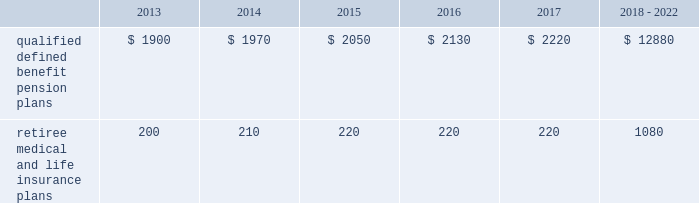Valuation techniques 2013 cash equivalents are mostly comprised of short-term money-market instruments and are valued at cost , which approximates fair value .
U.s .
Equity securities and international equity securities categorized as level 1 are traded on active national and international exchanges and are valued at their closing prices on the last trading day of the year .
For u.s .
Equity securities and international equity securities not traded on an active exchange , or if the closing price is not available , the trustee obtains indicative quotes from a pricing vendor , broker , or investment manager .
These securities are categorized as level 2 if the custodian obtains corroborated quotes from a pricing vendor or categorized as level 3 if the custodian obtains uncorroborated quotes from a broker or investment manager .
Commingled equity funds are public investment vehicles valued using the net asset value ( nav ) provided by the fund manager .
The nav is the total value of the fund divided by the number of shares outstanding .
Commingled equity funds are categorized as level 1 if traded at their nav on a nationally recognized securities exchange or categorized as level 2 if the nav is corroborated by observable market data ( e.g. , purchases or sales activity ) .
Fixed income securities categorized as level 2 are valued by the trustee using pricing models that use verifiable observable market data ( e.g .
Interest rates and yield curves observable at commonly quoted intervals ) , bids provided by brokers or dealers , or quoted prices of securities with similar characteristics .
Private equity funds , real estate funds , hedge funds , and fixed income securities categorized as level 3 are valued based on valuation models that include significant unobservable inputs and cannot be corroborated using verifiable observable market data .
Valuations for private equity funds and real estate funds are determined by the general partners , while hedge funds are valued by independent administrators .
Depending on the nature of the assets , the general partners or independent administrators use both the income and market approaches in their models .
The market approach consists of analyzing market transactions for comparable assets while the income approach uses earnings or the net present value of estimated future cash flows adjusted for liquidity and other risk factors .
Commodities categorized as level 1 are traded on an active commodity exchange and are valued at their closing prices on the last trading day of the year .
Commodities categorized as level 2 represent shares in a commingled commodity fund valued using the nav , which is corroborated by observable market data .
Contributions and expected benefit payments we generally determine funding requirements for our defined benefit pension plans in a manner consistent with cas and internal revenue code rules .
In 2012 , we made contributions of $ 3.6 billion related to our qualified defined benefit pension plans .
We plan to make contributions of approximately $ 1.5 billion related to the qualified defined benefit pension plans in 2013 .
In 2012 , we made contributions of $ 235 million related to our retiree medical and life insurance plans .
We expect no required contributions related to the retiree medical and life insurance plans in 2013 .
The table presents estimated future benefit payments , which reflect expected future employee service , as of december 31 , 2012 ( in millions ) : .
Defined contribution plans we maintain a number of defined contribution plans , most with 401 ( k ) features , that cover substantially all of our employees .
Under the provisions of our 401 ( k ) plans , we match most employees 2019 eligible contributions at rates specified in the plan documents .
Our contributions were $ 380 million in 2012 , $ 378 million in 2011 , and $ 379 million in 2010 , the majority of which were funded in our common stock .
Our defined contribution plans held approximately 48.6 million and 52.1 million shares of our common stock as of december 31 , 2012 and 2011. .
What is the ratio of the 2012 contribution to the anticipated employee contributions in 2013? 
Computations: (3.6 / 1.5)
Answer: 2.4. 